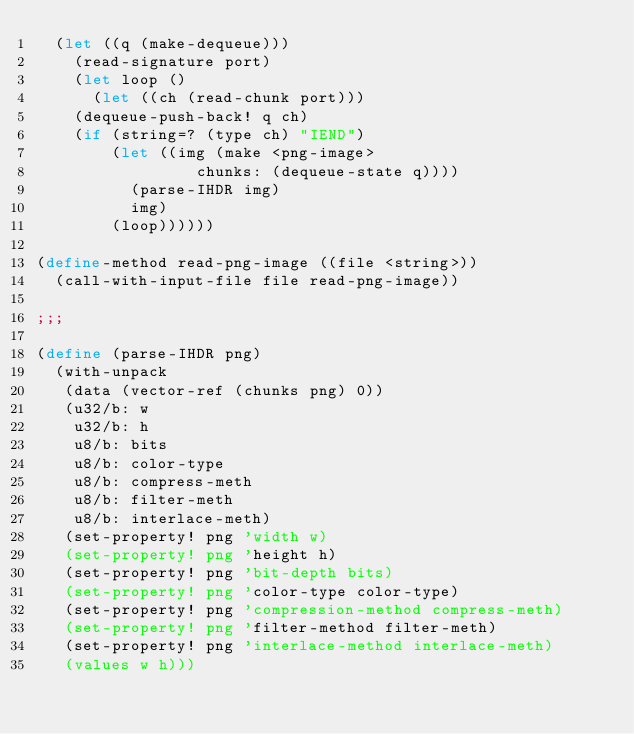<code> <loc_0><loc_0><loc_500><loc_500><_Scheme_>  (let ((q (make-dequeue)))
    (read-signature port)
    (let loop ()
      (let ((ch (read-chunk port)))
	(dequeue-push-back! q ch)
	(if (string=? (type ch) "IEND")
	    (let ((img (make <png-image>
			     chunks: (dequeue-state q))))
	      (parse-IHDR img)
	      img)
	    (loop))))))

(define-method read-png-image ((file <string>))
  (call-with-input-file file read-png-image))

;;;

(define (parse-IHDR png)
  (with-unpack
   (data (vector-ref (chunks png) 0))
   (u32/b: w
    u32/b: h
    u8/b: bits
    u8/b: color-type
    u8/b: compress-meth
    u8/b: filter-meth
    u8/b: interlace-meth)
   (set-property! png 'width w)
   (set-property! png 'height h)
   (set-property! png 'bit-depth bits)
   (set-property! png 'color-type color-type)
   (set-property! png 'compression-method compress-meth)
   (set-property! png 'filter-method filter-meth)
   (set-property! png 'interlace-method interlace-meth)
   (values w h)))
</code> 